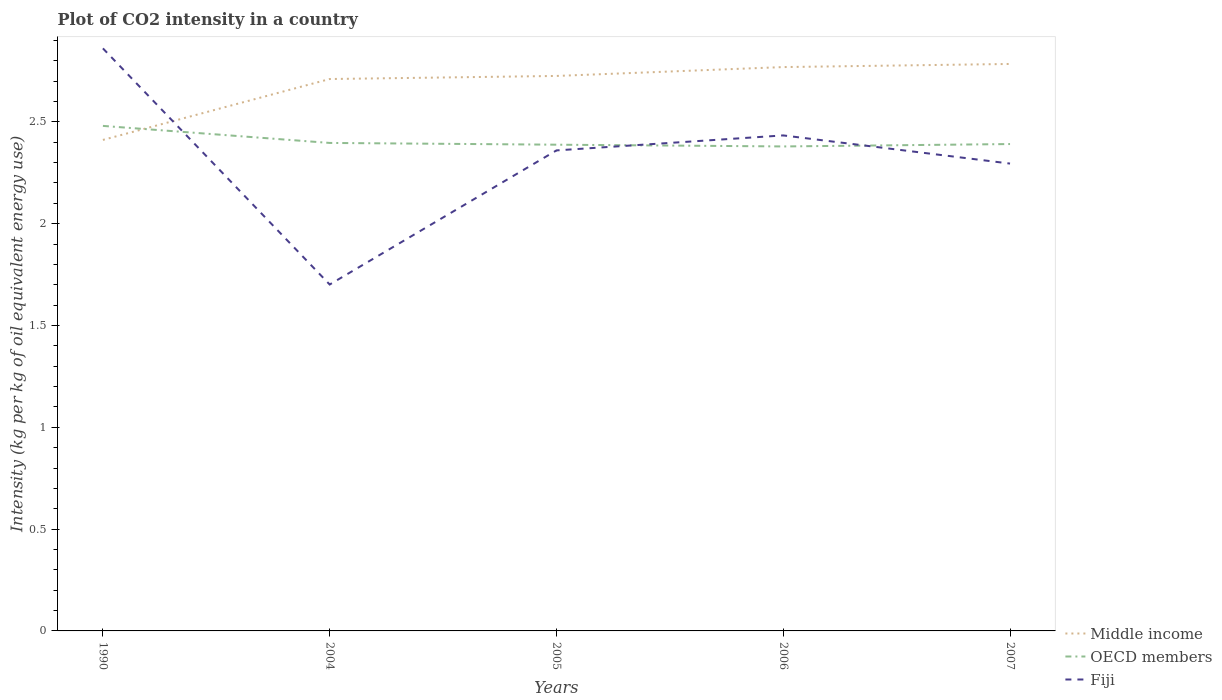Does the line corresponding to Fiji intersect with the line corresponding to OECD members?
Offer a terse response. Yes. Across all years, what is the maximum CO2 intensity in in Middle income?
Your response must be concise. 2.41. In which year was the CO2 intensity in in Middle income maximum?
Give a very brief answer. 1990. What is the total CO2 intensity in in Middle income in the graph?
Provide a succinct answer. -0.37. What is the difference between the highest and the second highest CO2 intensity in in Fiji?
Ensure brevity in your answer.  1.16. Is the CO2 intensity in in OECD members strictly greater than the CO2 intensity in in Fiji over the years?
Offer a very short reply. No. How many lines are there?
Offer a very short reply. 3. How many years are there in the graph?
Provide a succinct answer. 5. Are the values on the major ticks of Y-axis written in scientific E-notation?
Your answer should be very brief. No. Does the graph contain any zero values?
Offer a very short reply. No. Where does the legend appear in the graph?
Make the answer very short. Bottom right. What is the title of the graph?
Keep it short and to the point. Plot of CO2 intensity in a country. Does "OECD members" appear as one of the legend labels in the graph?
Offer a terse response. Yes. What is the label or title of the X-axis?
Your response must be concise. Years. What is the label or title of the Y-axis?
Make the answer very short. Intensity (kg per kg of oil equivalent energy use). What is the Intensity (kg per kg of oil equivalent energy use) in Middle income in 1990?
Provide a succinct answer. 2.41. What is the Intensity (kg per kg of oil equivalent energy use) in OECD members in 1990?
Keep it short and to the point. 2.48. What is the Intensity (kg per kg of oil equivalent energy use) of Fiji in 1990?
Provide a succinct answer. 2.86. What is the Intensity (kg per kg of oil equivalent energy use) of Middle income in 2004?
Make the answer very short. 2.71. What is the Intensity (kg per kg of oil equivalent energy use) of OECD members in 2004?
Your response must be concise. 2.4. What is the Intensity (kg per kg of oil equivalent energy use) of Fiji in 2004?
Ensure brevity in your answer.  1.7. What is the Intensity (kg per kg of oil equivalent energy use) of Middle income in 2005?
Offer a terse response. 2.73. What is the Intensity (kg per kg of oil equivalent energy use) of OECD members in 2005?
Provide a short and direct response. 2.39. What is the Intensity (kg per kg of oil equivalent energy use) of Fiji in 2005?
Your answer should be very brief. 2.36. What is the Intensity (kg per kg of oil equivalent energy use) of Middle income in 2006?
Make the answer very short. 2.77. What is the Intensity (kg per kg of oil equivalent energy use) in OECD members in 2006?
Offer a terse response. 2.38. What is the Intensity (kg per kg of oil equivalent energy use) of Fiji in 2006?
Offer a very short reply. 2.43. What is the Intensity (kg per kg of oil equivalent energy use) in Middle income in 2007?
Your answer should be compact. 2.78. What is the Intensity (kg per kg of oil equivalent energy use) of OECD members in 2007?
Give a very brief answer. 2.39. What is the Intensity (kg per kg of oil equivalent energy use) in Fiji in 2007?
Provide a short and direct response. 2.3. Across all years, what is the maximum Intensity (kg per kg of oil equivalent energy use) in Middle income?
Your response must be concise. 2.78. Across all years, what is the maximum Intensity (kg per kg of oil equivalent energy use) in OECD members?
Your answer should be very brief. 2.48. Across all years, what is the maximum Intensity (kg per kg of oil equivalent energy use) of Fiji?
Keep it short and to the point. 2.86. Across all years, what is the minimum Intensity (kg per kg of oil equivalent energy use) of Middle income?
Provide a short and direct response. 2.41. Across all years, what is the minimum Intensity (kg per kg of oil equivalent energy use) of OECD members?
Your answer should be very brief. 2.38. Across all years, what is the minimum Intensity (kg per kg of oil equivalent energy use) of Fiji?
Give a very brief answer. 1.7. What is the total Intensity (kg per kg of oil equivalent energy use) of Middle income in the graph?
Your answer should be compact. 13.4. What is the total Intensity (kg per kg of oil equivalent energy use) of OECD members in the graph?
Make the answer very short. 12.04. What is the total Intensity (kg per kg of oil equivalent energy use) in Fiji in the graph?
Make the answer very short. 11.65. What is the difference between the Intensity (kg per kg of oil equivalent energy use) of Middle income in 1990 and that in 2004?
Offer a very short reply. -0.3. What is the difference between the Intensity (kg per kg of oil equivalent energy use) of OECD members in 1990 and that in 2004?
Offer a terse response. 0.08. What is the difference between the Intensity (kg per kg of oil equivalent energy use) in Fiji in 1990 and that in 2004?
Ensure brevity in your answer.  1.16. What is the difference between the Intensity (kg per kg of oil equivalent energy use) in Middle income in 1990 and that in 2005?
Offer a very short reply. -0.31. What is the difference between the Intensity (kg per kg of oil equivalent energy use) of OECD members in 1990 and that in 2005?
Provide a short and direct response. 0.09. What is the difference between the Intensity (kg per kg of oil equivalent energy use) of Fiji in 1990 and that in 2005?
Provide a short and direct response. 0.5. What is the difference between the Intensity (kg per kg of oil equivalent energy use) of Middle income in 1990 and that in 2006?
Your answer should be very brief. -0.36. What is the difference between the Intensity (kg per kg of oil equivalent energy use) of OECD members in 1990 and that in 2006?
Make the answer very short. 0.1. What is the difference between the Intensity (kg per kg of oil equivalent energy use) of Fiji in 1990 and that in 2006?
Offer a terse response. 0.43. What is the difference between the Intensity (kg per kg of oil equivalent energy use) in Middle income in 1990 and that in 2007?
Your answer should be very brief. -0.37. What is the difference between the Intensity (kg per kg of oil equivalent energy use) of OECD members in 1990 and that in 2007?
Provide a succinct answer. 0.09. What is the difference between the Intensity (kg per kg of oil equivalent energy use) of Fiji in 1990 and that in 2007?
Your answer should be compact. 0.57. What is the difference between the Intensity (kg per kg of oil equivalent energy use) in Middle income in 2004 and that in 2005?
Give a very brief answer. -0.02. What is the difference between the Intensity (kg per kg of oil equivalent energy use) in OECD members in 2004 and that in 2005?
Provide a short and direct response. 0.01. What is the difference between the Intensity (kg per kg of oil equivalent energy use) in Fiji in 2004 and that in 2005?
Ensure brevity in your answer.  -0.66. What is the difference between the Intensity (kg per kg of oil equivalent energy use) of Middle income in 2004 and that in 2006?
Make the answer very short. -0.06. What is the difference between the Intensity (kg per kg of oil equivalent energy use) of OECD members in 2004 and that in 2006?
Your answer should be very brief. 0.02. What is the difference between the Intensity (kg per kg of oil equivalent energy use) of Fiji in 2004 and that in 2006?
Give a very brief answer. -0.73. What is the difference between the Intensity (kg per kg of oil equivalent energy use) of Middle income in 2004 and that in 2007?
Provide a succinct answer. -0.07. What is the difference between the Intensity (kg per kg of oil equivalent energy use) in OECD members in 2004 and that in 2007?
Your answer should be compact. 0.01. What is the difference between the Intensity (kg per kg of oil equivalent energy use) of Fiji in 2004 and that in 2007?
Keep it short and to the point. -0.59. What is the difference between the Intensity (kg per kg of oil equivalent energy use) of Middle income in 2005 and that in 2006?
Your response must be concise. -0.04. What is the difference between the Intensity (kg per kg of oil equivalent energy use) of OECD members in 2005 and that in 2006?
Your response must be concise. 0.01. What is the difference between the Intensity (kg per kg of oil equivalent energy use) in Fiji in 2005 and that in 2006?
Your response must be concise. -0.07. What is the difference between the Intensity (kg per kg of oil equivalent energy use) of Middle income in 2005 and that in 2007?
Make the answer very short. -0.06. What is the difference between the Intensity (kg per kg of oil equivalent energy use) of OECD members in 2005 and that in 2007?
Your answer should be compact. -0. What is the difference between the Intensity (kg per kg of oil equivalent energy use) of Fiji in 2005 and that in 2007?
Make the answer very short. 0.06. What is the difference between the Intensity (kg per kg of oil equivalent energy use) of Middle income in 2006 and that in 2007?
Your response must be concise. -0.02. What is the difference between the Intensity (kg per kg of oil equivalent energy use) of OECD members in 2006 and that in 2007?
Make the answer very short. -0.01. What is the difference between the Intensity (kg per kg of oil equivalent energy use) in Fiji in 2006 and that in 2007?
Make the answer very short. 0.14. What is the difference between the Intensity (kg per kg of oil equivalent energy use) of Middle income in 1990 and the Intensity (kg per kg of oil equivalent energy use) of OECD members in 2004?
Give a very brief answer. 0.01. What is the difference between the Intensity (kg per kg of oil equivalent energy use) of Middle income in 1990 and the Intensity (kg per kg of oil equivalent energy use) of Fiji in 2004?
Provide a succinct answer. 0.71. What is the difference between the Intensity (kg per kg of oil equivalent energy use) in OECD members in 1990 and the Intensity (kg per kg of oil equivalent energy use) in Fiji in 2004?
Ensure brevity in your answer.  0.78. What is the difference between the Intensity (kg per kg of oil equivalent energy use) in Middle income in 1990 and the Intensity (kg per kg of oil equivalent energy use) in OECD members in 2005?
Your answer should be very brief. 0.02. What is the difference between the Intensity (kg per kg of oil equivalent energy use) in Middle income in 1990 and the Intensity (kg per kg of oil equivalent energy use) in Fiji in 2005?
Provide a succinct answer. 0.05. What is the difference between the Intensity (kg per kg of oil equivalent energy use) in OECD members in 1990 and the Intensity (kg per kg of oil equivalent energy use) in Fiji in 2005?
Provide a short and direct response. 0.12. What is the difference between the Intensity (kg per kg of oil equivalent energy use) of Middle income in 1990 and the Intensity (kg per kg of oil equivalent energy use) of OECD members in 2006?
Offer a terse response. 0.03. What is the difference between the Intensity (kg per kg of oil equivalent energy use) of Middle income in 1990 and the Intensity (kg per kg of oil equivalent energy use) of Fiji in 2006?
Your answer should be compact. -0.02. What is the difference between the Intensity (kg per kg of oil equivalent energy use) in OECD members in 1990 and the Intensity (kg per kg of oil equivalent energy use) in Fiji in 2006?
Keep it short and to the point. 0.05. What is the difference between the Intensity (kg per kg of oil equivalent energy use) in Middle income in 1990 and the Intensity (kg per kg of oil equivalent energy use) in OECD members in 2007?
Your answer should be compact. 0.02. What is the difference between the Intensity (kg per kg of oil equivalent energy use) in Middle income in 1990 and the Intensity (kg per kg of oil equivalent energy use) in Fiji in 2007?
Make the answer very short. 0.12. What is the difference between the Intensity (kg per kg of oil equivalent energy use) in OECD members in 1990 and the Intensity (kg per kg of oil equivalent energy use) in Fiji in 2007?
Keep it short and to the point. 0.19. What is the difference between the Intensity (kg per kg of oil equivalent energy use) of Middle income in 2004 and the Intensity (kg per kg of oil equivalent energy use) of OECD members in 2005?
Provide a succinct answer. 0.32. What is the difference between the Intensity (kg per kg of oil equivalent energy use) of Middle income in 2004 and the Intensity (kg per kg of oil equivalent energy use) of Fiji in 2005?
Keep it short and to the point. 0.35. What is the difference between the Intensity (kg per kg of oil equivalent energy use) in OECD members in 2004 and the Intensity (kg per kg of oil equivalent energy use) in Fiji in 2005?
Your answer should be compact. 0.04. What is the difference between the Intensity (kg per kg of oil equivalent energy use) of Middle income in 2004 and the Intensity (kg per kg of oil equivalent energy use) of OECD members in 2006?
Give a very brief answer. 0.33. What is the difference between the Intensity (kg per kg of oil equivalent energy use) of Middle income in 2004 and the Intensity (kg per kg of oil equivalent energy use) of Fiji in 2006?
Give a very brief answer. 0.28. What is the difference between the Intensity (kg per kg of oil equivalent energy use) in OECD members in 2004 and the Intensity (kg per kg of oil equivalent energy use) in Fiji in 2006?
Keep it short and to the point. -0.04. What is the difference between the Intensity (kg per kg of oil equivalent energy use) in Middle income in 2004 and the Intensity (kg per kg of oil equivalent energy use) in OECD members in 2007?
Offer a terse response. 0.32. What is the difference between the Intensity (kg per kg of oil equivalent energy use) of Middle income in 2004 and the Intensity (kg per kg of oil equivalent energy use) of Fiji in 2007?
Your answer should be very brief. 0.42. What is the difference between the Intensity (kg per kg of oil equivalent energy use) of OECD members in 2004 and the Intensity (kg per kg of oil equivalent energy use) of Fiji in 2007?
Make the answer very short. 0.1. What is the difference between the Intensity (kg per kg of oil equivalent energy use) of Middle income in 2005 and the Intensity (kg per kg of oil equivalent energy use) of OECD members in 2006?
Your response must be concise. 0.35. What is the difference between the Intensity (kg per kg of oil equivalent energy use) in Middle income in 2005 and the Intensity (kg per kg of oil equivalent energy use) in Fiji in 2006?
Keep it short and to the point. 0.29. What is the difference between the Intensity (kg per kg of oil equivalent energy use) in OECD members in 2005 and the Intensity (kg per kg of oil equivalent energy use) in Fiji in 2006?
Your response must be concise. -0.05. What is the difference between the Intensity (kg per kg of oil equivalent energy use) in Middle income in 2005 and the Intensity (kg per kg of oil equivalent energy use) in OECD members in 2007?
Your answer should be very brief. 0.33. What is the difference between the Intensity (kg per kg of oil equivalent energy use) of Middle income in 2005 and the Intensity (kg per kg of oil equivalent energy use) of Fiji in 2007?
Keep it short and to the point. 0.43. What is the difference between the Intensity (kg per kg of oil equivalent energy use) of OECD members in 2005 and the Intensity (kg per kg of oil equivalent energy use) of Fiji in 2007?
Your response must be concise. 0.09. What is the difference between the Intensity (kg per kg of oil equivalent energy use) of Middle income in 2006 and the Intensity (kg per kg of oil equivalent energy use) of OECD members in 2007?
Your answer should be very brief. 0.38. What is the difference between the Intensity (kg per kg of oil equivalent energy use) of Middle income in 2006 and the Intensity (kg per kg of oil equivalent energy use) of Fiji in 2007?
Provide a succinct answer. 0.47. What is the difference between the Intensity (kg per kg of oil equivalent energy use) of OECD members in 2006 and the Intensity (kg per kg of oil equivalent energy use) of Fiji in 2007?
Your answer should be very brief. 0.08. What is the average Intensity (kg per kg of oil equivalent energy use) in Middle income per year?
Ensure brevity in your answer.  2.68. What is the average Intensity (kg per kg of oil equivalent energy use) of OECD members per year?
Your answer should be very brief. 2.41. What is the average Intensity (kg per kg of oil equivalent energy use) of Fiji per year?
Offer a very short reply. 2.33. In the year 1990, what is the difference between the Intensity (kg per kg of oil equivalent energy use) of Middle income and Intensity (kg per kg of oil equivalent energy use) of OECD members?
Give a very brief answer. -0.07. In the year 1990, what is the difference between the Intensity (kg per kg of oil equivalent energy use) in Middle income and Intensity (kg per kg of oil equivalent energy use) in Fiji?
Offer a very short reply. -0.45. In the year 1990, what is the difference between the Intensity (kg per kg of oil equivalent energy use) in OECD members and Intensity (kg per kg of oil equivalent energy use) in Fiji?
Make the answer very short. -0.38. In the year 2004, what is the difference between the Intensity (kg per kg of oil equivalent energy use) of Middle income and Intensity (kg per kg of oil equivalent energy use) of OECD members?
Ensure brevity in your answer.  0.31. In the year 2004, what is the difference between the Intensity (kg per kg of oil equivalent energy use) of Middle income and Intensity (kg per kg of oil equivalent energy use) of Fiji?
Provide a short and direct response. 1.01. In the year 2004, what is the difference between the Intensity (kg per kg of oil equivalent energy use) of OECD members and Intensity (kg per kg of oil equivalent energy use) of Fiji?
Offer a terse response. 0.7. In the year 2005, what is the difference between the Intensity (kg per kg of oil equivalent energy use) in Middle income and Intensity (kg per kg of oil equivalent energy use) in OECD members?
Offer a very short reply. 0.34. In the year 2005, what is the difference between the Intensity (kg per kg of oil equivalent energy use) in Middle income and Intensity (kg per kg of oil equivalent energy use) in Fiji?
Provide a short and direct response. 0.37. In the year 2005, what is the difference between the Intensity (kg per kg of oil equivalent energy use) in OECD members and Intensity (kg per kg of oil equivalent energy use) in Fiji?
Keep it short and to the point. 0.03. In the year 2006, what is the difference between the Intensity (kg per kg of oil equivalent energy use) in Middle income and Intensity (kg per kg of oil equivalent energy use) in OECD members?
Your answer should be compact. 0.39. In the year 2006, what is the difference between the Intensity (kg per kg of oil equivalent energy use) in Middle income and Intensity (kg per kg of oil equivalent energy use) in Fiji?
Your answer should be compact. 0.34. In the year 2006, what is the difference between the Intensity (kg per kg of oil equivalent energy use) in OECD members and Intensity (kg per kg of oil equivalent energy use) in Fiji?
Give a very brief answer. -0.05. In the year 2007, what is the difference between the Intensity (kg per kg of oil equivalent energy use) of Middle income and Intensity (kg per kg of oil equivalent energy use) of OECD members?
Your answer should be very brief. 0.39. In the year 2007, what is the difference between the Intensity (kg per kg of oil equivalent energy use) in Middle income and Intensity (kg per kg of oil equivalent energy use) in Fiji?
Provide a succinct answer. 0.49. In the year 2007, what is the difference between the Intensity (kg per kg of oil equivalent energy use) of OECD members and Intensity (kg per kg of oil equivalent energy use) of Fiji?
Your answer should be very brief. 0.1. What is the ratio of the Intensity (kg per kg of oil equivalent energy use) of Middle income in 1990 to that in 2004?
Your answer should be compact. 0.89. What is the ratio of the Intensity (kg per kg of oil equivalent energy use) of OECD members in 1990 to that in 2004?
Your answer should be compact. 1.03. What is the ratio of the Intensity (kg per kg of oil equivalent energy use) in Fiji in 1990 to that in 2004?
Your answer should be very brief. 1.68. What is the ratio of the Intensity (kg per kg of oil equivalent energy use) of Middle income in 1990 to that in 2005?
Offer a very short reply. 0.88. What is the ratio of the Intensity (kg per kg of oil equivalent energy use) in OECD members in 1990 to that in 2005?
Your answer should be very brief. 1.04. What is the ratio of the Intensity (kg per kg of oil equivalent energy use) of Fiji in 1990 to that in 2005?
Your answer should be compact. 1.21. What is the ratio of the Intensity (kg per kg of oil equivalent energy use) in Middle income in 1990 to that in 2006?
Provide a succinct answer. 0.87. What is the ratio of the Intensity (kg per kg of oil equivalent energy use) of OECD members in 1990 to that in 2006?
Give a very brief answer. 1.04. What is the ratio of the Intensity (kg per kg of oil equivalent energy use) of Fiji in 1990 to that in 2006?
Provide a short and direct response. 1.18. What is the ratio of the Intensity (kg per kg of oil equivalent energy use) in Middle income in 1990 to that in 2007?
Provide a succinct answer. 0.87. What is the ratio of the Intensity (kg per kg of oil equivalent energy use) in OECD members in 1990 to that in 2007?
Provide a succinct answer. 1.04. What is the ratio of the Intensity (kg per kg of oil equivalent energy use) in Fiji in 1990 to that in 2007?
Your response must be concise. 1.25. What is the ratio of the Intensity (kg per kg of oil equivalent energy use) in OECD members in 2004 to that in 2005?
Make the answer very short. 1. What is the ratio of the Intensity (kg per kg of oil equivalent energy use) in Fiji in 2004 to that in 2005?
Give a very brief answer. 0.72. What is the ratio of the Intensity (kg per kg of oil equivalent energy use) in Middle income in 2004 to that in 2006?
Provide a succinct answer. 0.98. What is the ratio of the Intensity (kg per kg of oil equivalent energy use) of OECD members in 2004 to that in 2006?
Make the answer very short. 1.01. What is the ratio of the Intensity (kg per kg of oil equivalent energy use) in Fiji in 2004 to that in 2006?
Ensure brevity in your answer.  0.7. What is the ratio of the Intensity (kg per kg of oil equivalent energy use) of Middle income in 2004 to that in 2007?
Your answer should be compact. 0.97. What is the ratio of the Intensity (kg per kg of oil equivalent energy use) of Fiji in 2004 to that in 2007?
Your answer should be compact. 0.74. What is the ratio of the Intensity (kg per kg of oil equivalent energy use) of Middle income in 2005 to that in 2006?
Provide a short and direct response. 0.98. What is the ratio of the Intensity (kg per kg of oil equivalent energy use) of OECD members in 2005 to that in 2006?
Keep it short and to the point. 1. What is the ratio of the Intensity (kg per kg of oil equivalent energy use) of Fiji in 2005 to that in 2006?
Keep it short and to the point. 0.97. What is the ratio of the Intensity (kg per kg of oil equivalent energy use) in Middle income in 2005 to that in 2007?
Offer a very short reply. 0.98. What is the ratio of the Intensity (kg per kg of oil equivalent energy use) of Fiji in 2005 to that in 2007?
Offer a very short reply. 1.03. What is the ratio of the Intensity (kg per kg of oil equivalent energy use) in Middle income in 2006 to that in 2007?
Make the answer very short. 0.99. What is the ratio of the Intensity (kg per kg of oil equivalent energy use) of OECD members in 2006 to that in 2007?
Your answer should be very brief. 1. What is the ratio of the Intensity (kg per kg of oil equivalent energy use) in Fiji in 2006 to that in 2007?
Keep it short and to the point. 1.06. What is the difference between the highest and the second highest Intensity (kg per kg of oil equivalent energy use) in Middle income?
Your response must be concise. 0.02. What is the difference between the highest and the second highest Intensity (kg per kg of oil equivalent energy use) in OECD members?
Your answer should be compact. 0.08. What is the difference between the highest and the second highest Intensity (kg per kg of oil equivalent energy use) in Fiji?
Provide a succinct answer. 0.43. What is the difference between the highest and the lowest Intensity (kg per kg of oil equivalent energy use) in Middle income?
Offer a terse response. 0.37. What is the difference between the highest and the lowest Intensity (kg per kg of oil equivalent energy use) in OECD members?
Offer a terse response. 0.1. What is the difference between the highest and the lowest Intensity (kg per kg of oil equivalent energy use) of Fiji?
Keep it short and to the point. 1.16. 